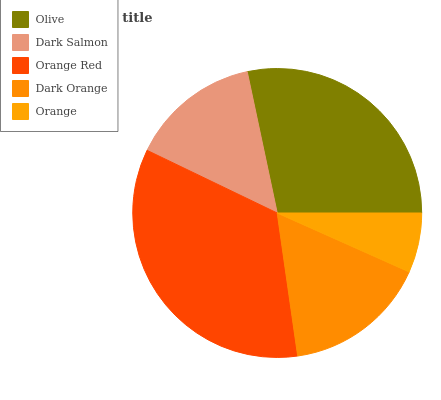Is Orange the minimum?
Answer yes or no. Yes. Is Orange Red the maximum?
Answer yes or no. Yes. Is Dark Salmon the minimum?
Answer yes or no. No. Is Dark Salmon the maximum?
Answer yes or no. No. Is Olive greater than Dark Salmon?
Answer yes or no. Yes. Is Dark Salmon less than Olive?
Answer yes or no. Yes. Is Dark Salmon greater than Olive?
Answer yes or no. No. Is Olive less than Dark Salmon?
Answer yes or no. No. Is Dark Orange the high median?
Answer yes or no. Yes. Is Dark Orange the low median?
Answer yes or no. Yes. Is Dark Salmon the high median?
Answer yes or no. No. Is Orange Red the low median?
Answer yes or no. No. 